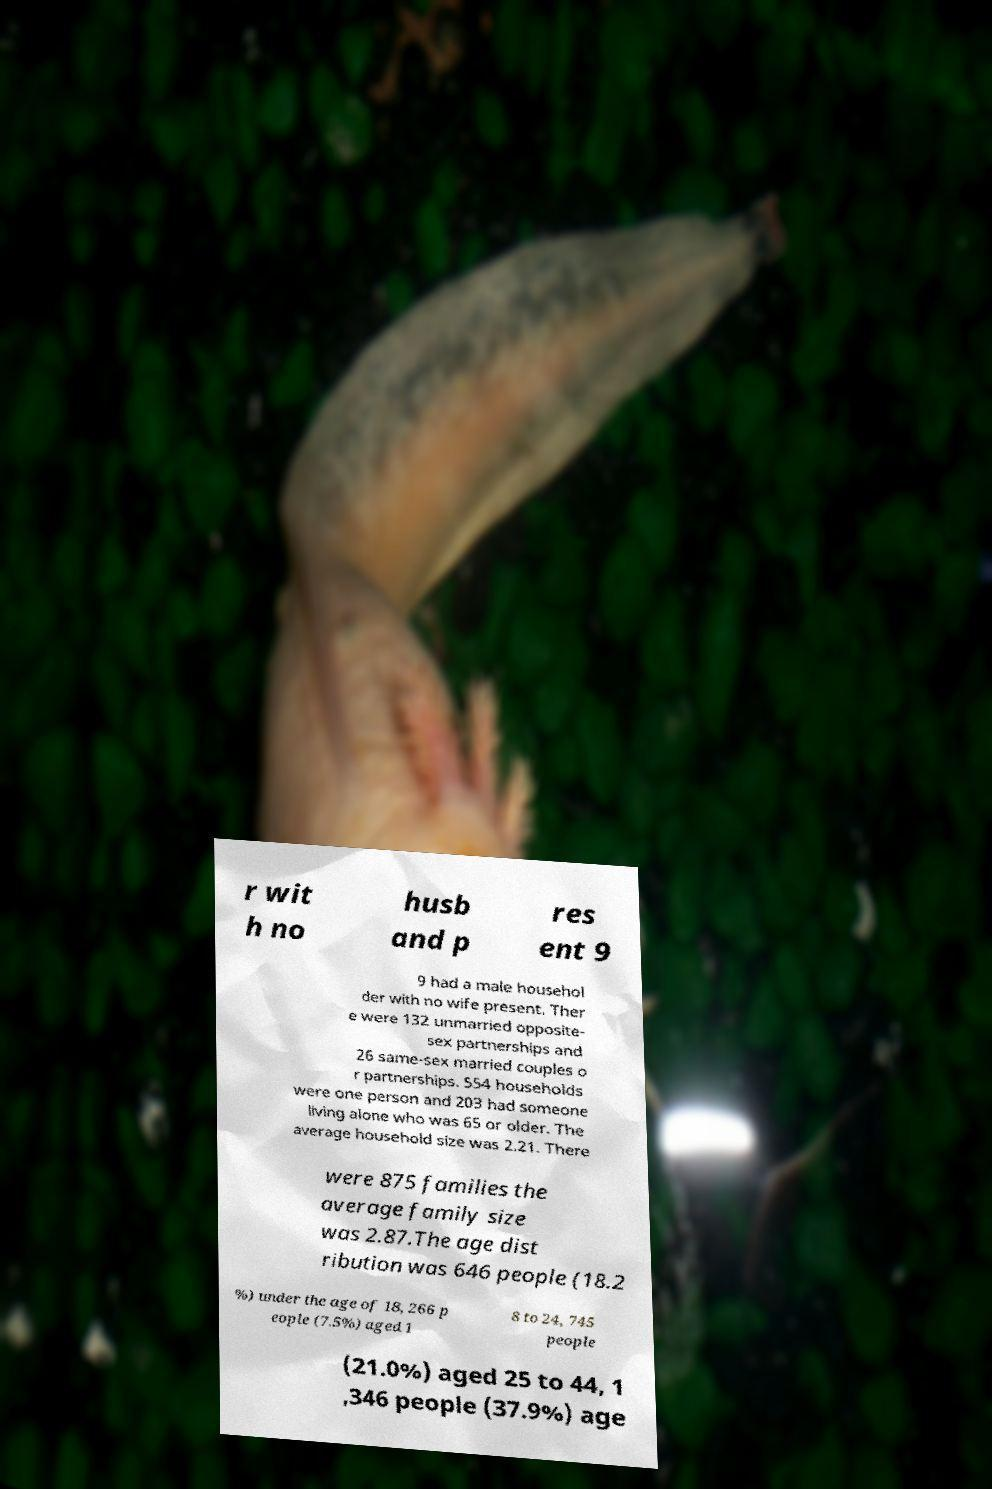Please identify and transcribe the text found in this image. r wit h no husb and p res ent 9 9 had a male househol der with no wife present. Ther e were 132 unmarried opposite- sex partnerships and 26 same-sex married couples o r partnerships. 554 households were one person and 203 had someone living alone who was 65 or older. The average household size was 2.21. There were 875 families the average family size was 2.87.The age dist ribution was 646 people (18.2 %) under the age of 18, 266 p eople (7.5%) aged 1 8 to 24, 745 people (21.0%) aged 25 to 44, 1 ,346 people (37.9%) age 